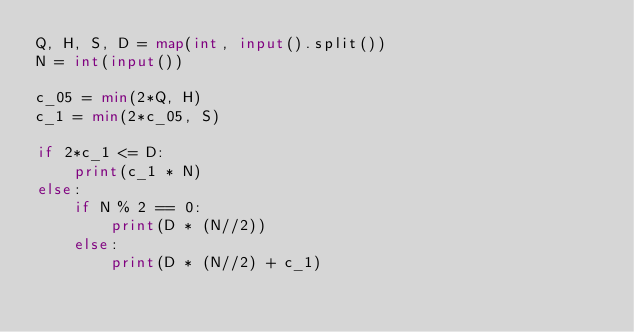Convert code to text. <code><loc_0><loc_0><loc_500><loc_500><_Python_>Q, H, S, D = map(int, input().split())
N = int(input())

c_05 = min(2*Q, H)
c_1 = min(2*c_05, S)

if 2*c_1 <= D:
    print(c_1 * N)
else:
    if N % 2 == 0:
        print(D * (N//2))
    else:
        print(D * (N//2) + c_1)</code> 